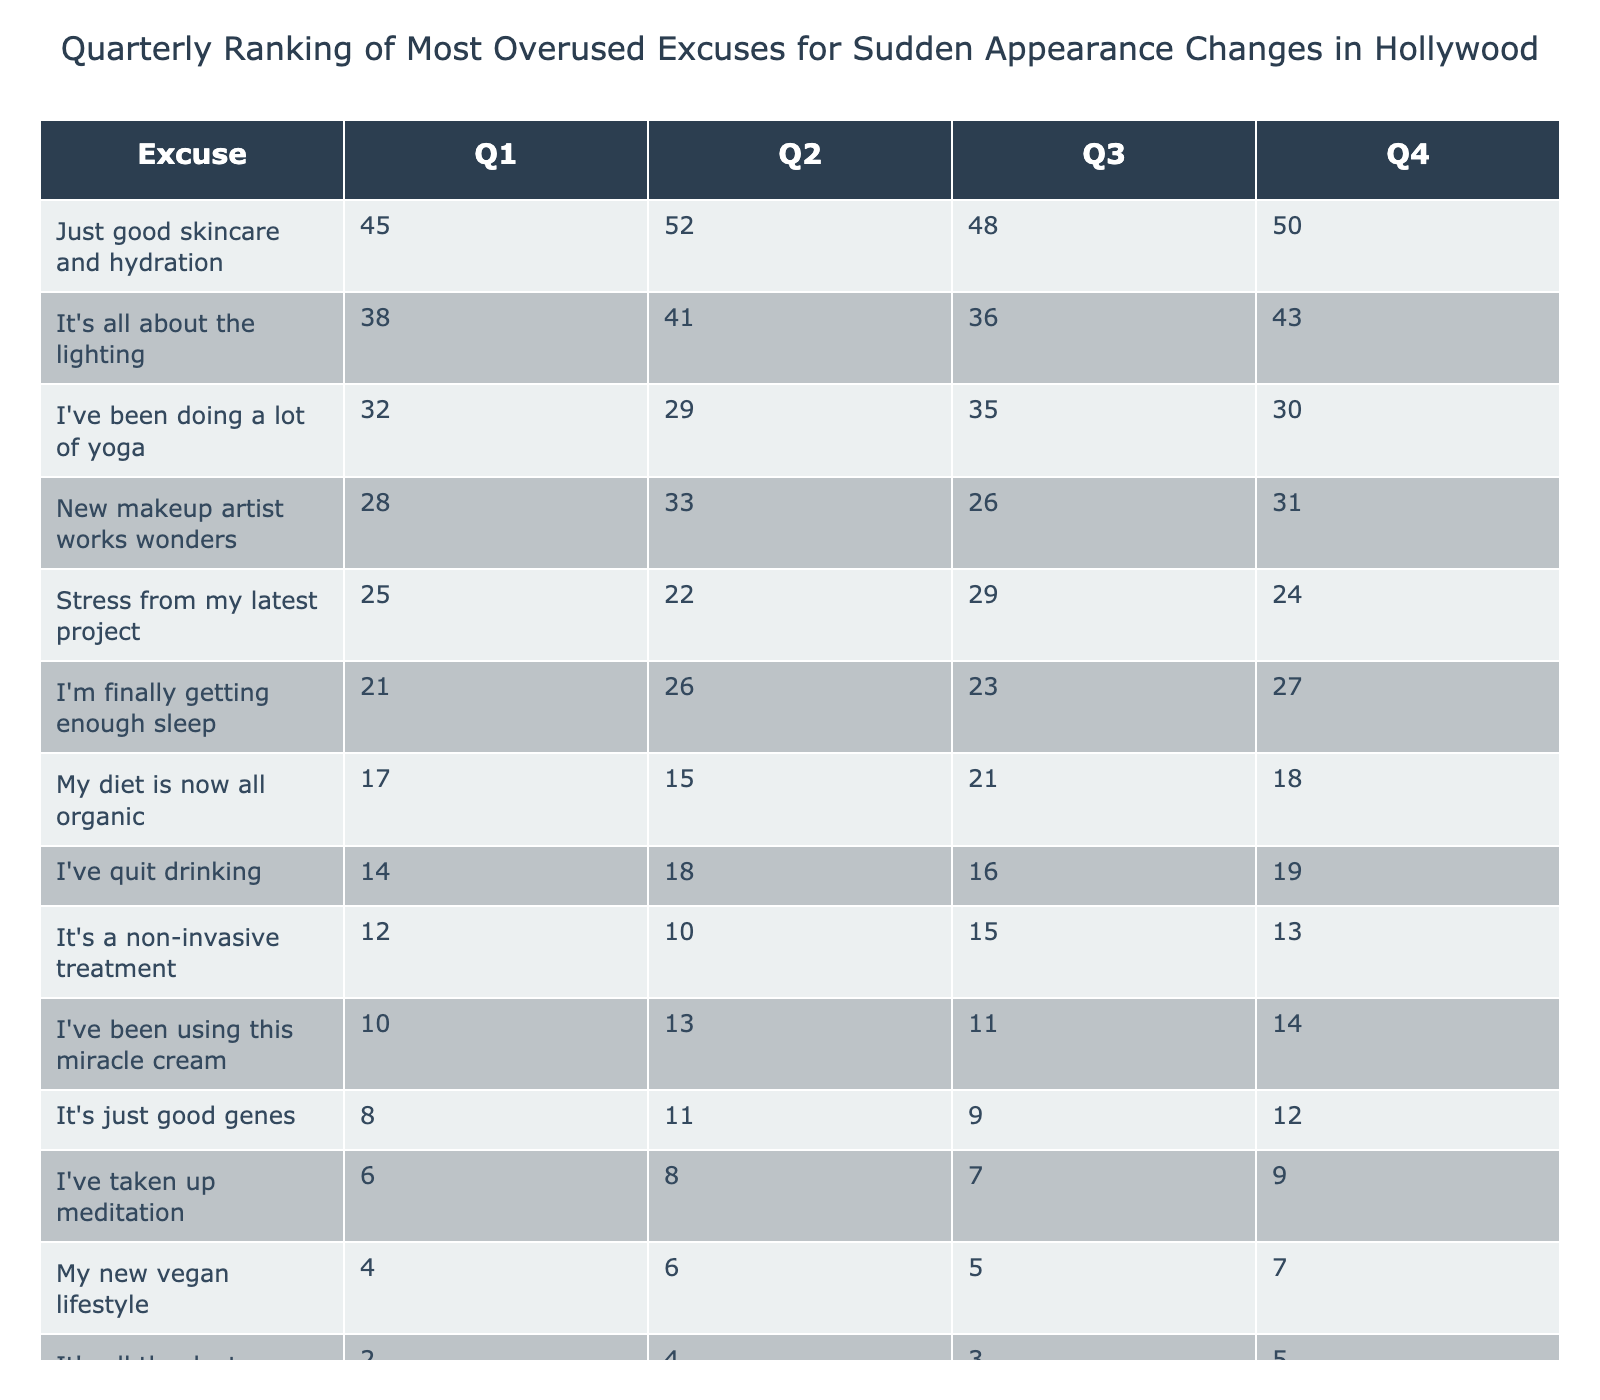What's the most popular excuse in Q1? In Q1, the excuse with the highest value is "Just good skincare and hydration," which has a score of 45.
Answer: 45 What excuse had the lowest score in Q4? In Q4, "It's all thanks to my personal trainer" had the lowest score at 5.
Answer: 5 Which excuse showed a steady increase from Q1 to Q2? "It's all about the lighting" increased from 38 in Q1 to 41 in Q2, indicating a steady increase.
Answer: Yes What excuse had the largest decline from Q1 to Q3? "I've been doing a lot of yoga" declined from 32 in Q1 to 35 in Q3, showing a change of -3. This is the largest decline among the excuses listed.
Answer: "I've been doing a lot of yoga" What is the average score for "I'm finally getting enough sleep"? The scores for "I'm finally getting enough sleep" are 21, 26, 23, and 27. Adding these gives 97 and dividing by 4 gives an average of 24.25.
Answer: 24.25 Which excuse had the highest total score across all four quarters? Adding all scores for each excuse, "Just good skincare and hydration" has the highest total score of 195 across the four quarters.
Answer: 195 How many excuses had a score greater than 30 in Q1? In Q1, there are three excuses with scores greater than 30: "Just good skincare and hydration" (45), "It's all about the lighting" (38), and "I've been doing a lot of yoga" (32).
Answer: 3 What excuse was more popular in Q2 than in Q4? "New makeup artist works wonders" increased from 33 in Q2 to 31 in Q4. Therefore, it was more popular in Q2 compared to Q4.
Answer: "New makeup artist works wonders" Which quarter had the highest total score for all excuses combined? The total scores for all excuses across quarters are: Q1 = 314, Q2 = 317, Q3 = 288, and Q4 = 294. Therefore, Q2 had the highest total score at 317.
Answer: Q2 